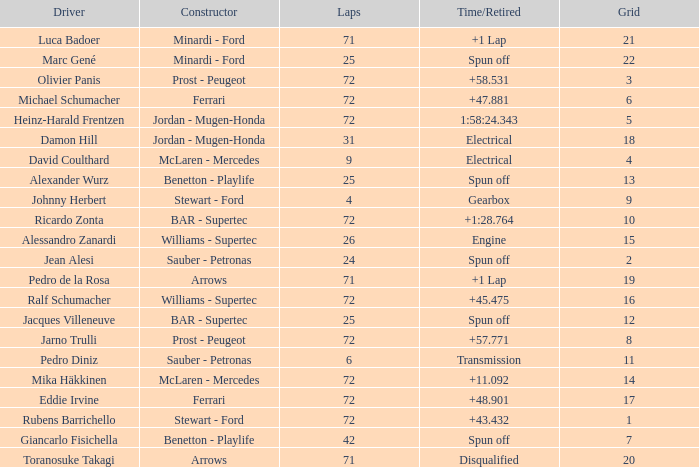How many laps did Ricardo Zonta drive with a grid less than 14? 72.0. 